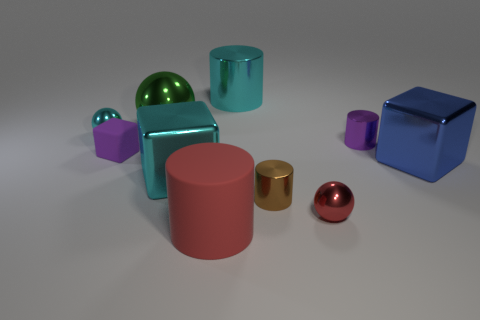Is there any other thing that has the same color as the big matte object?
Provide a succinct answer. Yes. There is a metal cylinder behind the tiny cyan shiny ball; is it the same size as the thing that is on the right side of the small purple metallic object?
Offer a very short reply. Yes. There is a cyan thing that is behind the tiny ball that is on the left side of the tiny purple rubber thing; what shape is it?
Ensure brevity in your answer.  Cylinder. There is a brown cylinder; is it the same size as the metallic cylinder that is to the right of the brown thing?
Keep it short and to the point. Yes. What size is the shiny cylinder behind the tiny cylinder that is behind the metallic block in front of the big blue thing?
Provide a short and direct response. Large. How many objects are big blocks that are to the right of the brown cylinder or big red rubber cubes?
Give a very brief answer. 1. What number of brown metal objects are on the left side of the big cyan object behind the cyan ball?
Your answer should be very brief. 0. Is the number of cylinders left of the tiny brown metal thing greater than the number of big green shiny things?
Make the answer very short. Yes. There is a thing that is both in front of the purple metal thing and to the left of the green object; what is its size?
Offer a very short reply. Small. The metallic thing that is both in front of the tiny purple rubber object and to the right of the red sphere has what shape?
Offer a very short reply. Cube. 